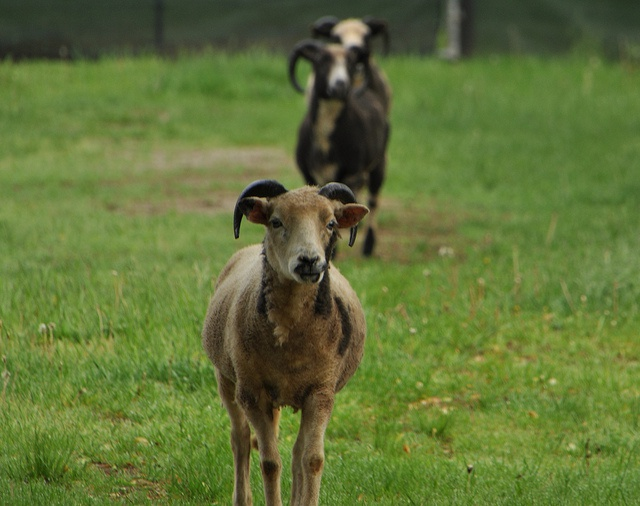Describe the objects in this image and their specific colors. I can see sheep in black and gray tones, sheep in black, darkgreen, and gray tones, and sheep in black, gray, darkgreen, and tan tones in this image. 